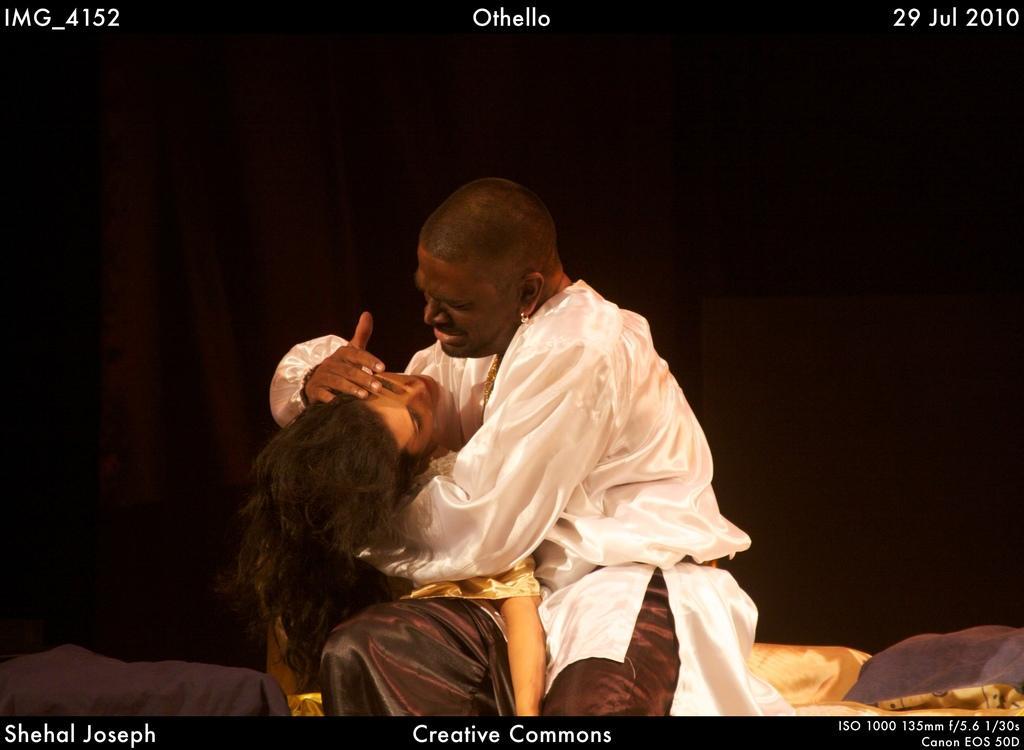In one or two sentences, can you explain what this image depicts? In this image we can see a man is sitting, he is wearing the white shirt, and holding a woman in the hands, at background here it is dark. 